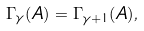Convert formula to latex. <formula><loc_0><loc_0><loc_500><loc_500>\Gamma _ { \gamma } ( A ) = \Gamma _ { \gamma + 1 } ( A ) ,</formula> 